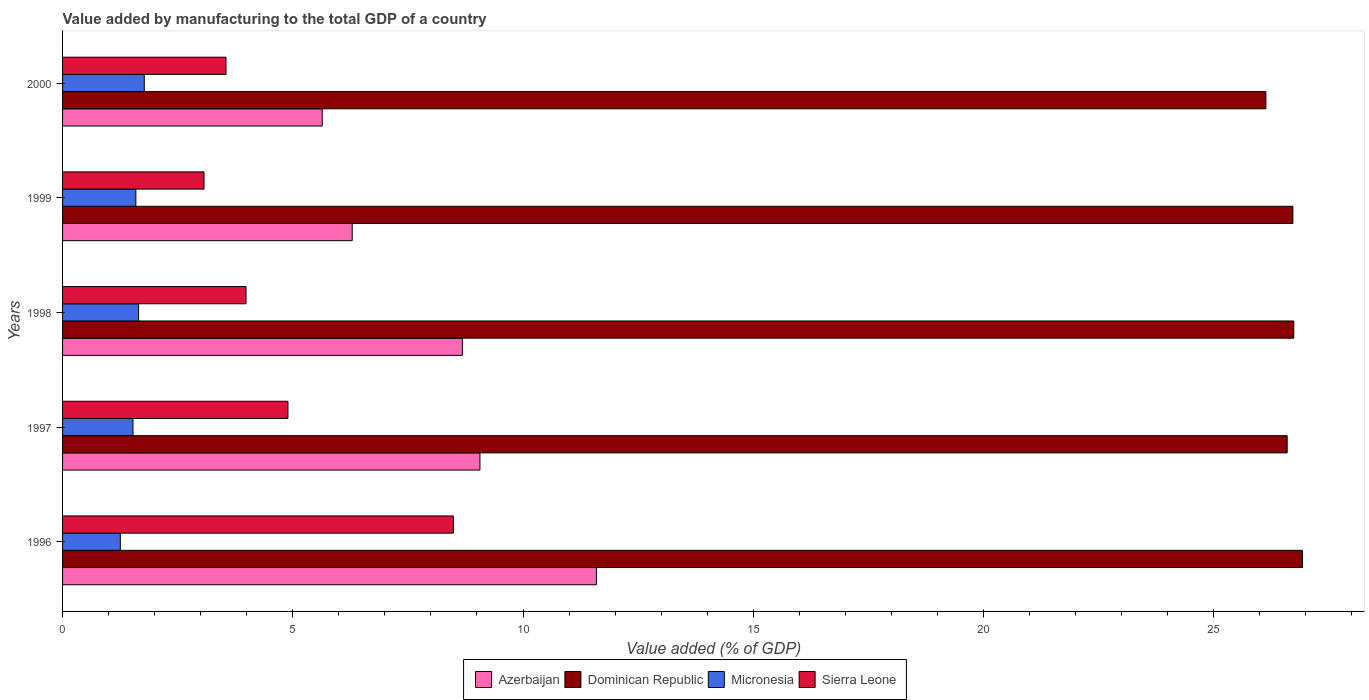How many different coloured bars are there?
Make the answer very short. 4. How many groups of bars are there?
Keep it short and to the point. 5. How many bars are there on the 3rd tick from the bottom?
Keep it short and to the point. 4. What is the value added by manufacturing to the total GDP in Dominican Republic in 1997?
Your response must be concise. 26.59. Across all years, what is the maximum value added by manufacturing to the total GDP in Sierra Leone?
Provide a succinct answer. 8.49. Across all years, what is the minimum value added by manufacturing to the total GDP in Sierra Leone?
Ensure brevity in your answer.  3.07. In which year was the value added by manufacturing to the total GDP in Dominican Republic maximum?
Your answer should be very brief. 1996. In which year was the value added by manufacturing to the total GDP in Micronesia minimum?
Offer a very short reply. 1996. What is the total value added by manufacturing to the total GDP in Sierra Leone in the graph?
Keep it short and to the point. 23.99. What is the difference between the value added by manufacturing to the total GDP in Dominican Republic in 1997 and that in 2000?
Your response must be concise. 0.46. What is the difference between the value added by manufacturing to the total GDP in Micronesia in 1997 and the value added by manufacturing to the total GDP in Sierra Leone in 1999?
Your response must be concise. -1.54. What is the average value added by manufacturing to the total GDP in Micronesia per year?
Your answer should be compact. 1.56. In the year 1999, what is the difference between the value added by manufacturing to the total GDP in Micronesia and value added by manufacturing to the total GDP in Dominican Republic?
Your answer should be very brief. -25.13. In how many years, is the value added by manufacturing to the total GDP in Azerbaijan greater than 13 %?
Your answer should be compact. 0. What is the ratio of the value added by manufacturing to the total GDP in Azerbaijan in 1996 to that in 2000?
Ensure brevity in your answer.  2.06. What is the difference between the highest and the second highest value added by manufacturing to the total GDP in Azerbaijan?
Offer a very short reply. 2.53. What is the difference between the highest and the lowest value added by manufacturing to the total GDP in Azerbaijan?
Your response must be concise. 5.95. In how many years, is the value added by manufacturing to the total GDP in Micronesia greater than the average value added by manufacturing to the total GDP in Micronesia taken over all years?
Provide a succinct answer. 3. Is the sum of the value added by manufacturing to the total GDP in Azerbaijan in 1998 and 2000 greater than the maximum value added by manufacturing to the total GDP in Sierra Leone across all years?
Offer a very short reply. Yes. What does the 2nd bar from the top in 1997 represents?
Keep it short and to the point. Micronesia. What does the 3rd bar from the bottom in 1999 represents?
Ensure brevity in your answer.  Micronesia. How many bars are there?
Make the answer very short. 20. Are all the bars in the graph horizontal?
Offer a very short reply. Yes. How many years are there in the graph?
Provide a succinct answer. 5. Does the graph contain any zero values?
Ensure brevity in your answer.  No. Does the graph contain grids?
Keep it short and to the point. No. How are the legend labels stacked?
Provide a succinct answer. Horizontal. What is the title of the graph?
Make the answer very short. Value added by manufacturing to the total GDP of a country. What is the label or title of the X-axis?
Your answer should be very brief. Value added (% of GDP). What is the label or title of the Y-axis?
Make the answer very short. Years. What is the Value added (% of GDP) of Azerbaijan in 1996?
Offer a terse response. 11.59. What is the Value added (% of GDP) of Dominican Republic in 1996?
Offer a terse response. 26.93. What is the Value added (% of GDP) in Micronesia in 1996?
Provide a short and direct response. 1.25. What is the Value added (% of GDP) of Sierra Leone in 1996?
Offer a terse response. 8.49. What is the Value added (% of GDP) of Azerbaijan in 1997?
Provide a succinct answer. 9.06. What is the Value added (% of GDP) in Dominican Republic in 1997?
Offer a very short reply. 26.59. What is the Value added (% of GDP) in Micronesia in 1997?
Your response must be concise. 1.53. What is the Value added (% of GDP) in Sierra Leone in 1997?
Give a very brief answer. 4.89. What is the Value added (% of GDP) in Azerbaijan in 1998?
Ensure brevity in your answer.  8.68. What is the Value added (% of GDP) in Dominican Republic in 1998?
Ensure brevity in your answer.  26.74. What is the Value added (% of GDP) of Micronesia in 1998?
Your answer should be compact. 1.65. What is the Value added (% of GDP) in Sierra Leone in 1998?
Ensure brevity in your answer.  3.98. What is the Value added (% of GDP) of Azerbaijan in 1999?
Your response must be concise. 6.29. What is the Value added (% of GDP) in Dominican Republic in 1999?
Provide a succinct answer. 26.72. What is the Value added (% of GDP) of Micronesia in 1999?
Provide a succinct answer. 1.59. What is the Value added (% of GDP) in Sierra Leone in 1999?
Provide a short and direct response. 3.07. What is the Value added (% of GDP) of Azerbaijan in 2000?
Your response must be concise. 5.64. What is the Value added (% of GDP) of Dominican Republic in 2000?
Ensure brevity in your answer.  26.13. What is the Value added (% of GDP) in Micronesia in 2000?
Provide a succinct answer. 1.77. What is the Value added (% of GDP) in Sierra Leone in 2000?
Provide a short and direct response. 3.55. Across all years, what is the maximum Value added (% of GDP) of Azerbaijan?
Your answer should be very brief. 11.59. Across all years, what is the maximum Value added (% of GDP) of Dominican Republic?
Your response must be concise. 26.93. Across all years, what is the maximum Value added (% of GDP) of Micronesia?
Your answer should be compact. 1.77. Across all years, what is the maximum Value added (% of GDP) of Sierra Leone?
Your answer should be very brief. 8.49. Across all years, what is the minimum Value added (% of GDP) of Azerbaijan?
Your answer should be compact. 5.64. Across all years, what is the minimum Value added (% of GDP) in Dominican Republic?
Your answer should be very brief. 26.13. Across all years, what is the minimum Value added (% of GDP) of Micronesia?
Provide a short and direct response. 1.25. Across all years, what is the minimum Value added (% of GDP) in Sierra Leone?
Provide a succinct answer. 3.07. What is the total Value added (% of GDP) in Azerbaijan in the graph?
Give a very brief answer. 41.27. What is the total Value added (% of GDP) in Dominican Republic in the graph?
Make the answer very short. 133.11. What is the total Value added (% of GDP) of Micronesia in the graph?
Give a very brief answer. 7.8. What is the total Value added (% of GDP) in Sierra Leone in the graph?
Give a very brief answer. 23.99. What is the difference between the Value added (% of GDP) in Azerbaijan in 1996 and that in 1997?
Offer a very short reply. 2.53. What is the difference between the Value added (% of GDP) of Dominican Republic in 1996 and that in 1997?
Give a very brief answer. 0.33. What is the difference between the Value added (% of GDP) in Micronesia in 1996 and that in 1997?
Offer a very short reply. -0.28. What is the difference between the Value added (% of GDP) of Sierra Leone in 1996 and that in 1997?
Keep it short and to the point. 3.59. What is the difference between the Value added (% of GDP) of Azerbaijan in 1996 and that in 1998?
Your response must be concise. 2.91. What is the difference between the Value added (% of GDP) in Dominican Republic in 1996 and that in 1998?
Your answer should be compact. 0.19. What is the difference between the Value added (% of GDP) of Micronesia in 1996 and that in 1998?
Keep it short and to the point. -0.4. What is the difference between the Value added (% of GDP) in Sierra Leone in 1996 and that in 1998?
Offer a terse response. 4.5. What is the difference between the Value added (% of GDP) of Azerbaijan in 1996 and that in 1999?
Your response must be concise. 5.3. What is the difference between the Value added (% of GDP) of Dominican Republic in 1996 and that in 1999?
Provide a short and direct response. 0.21. What is the difference between the Value added (% of GDP) of Micronesia in 1996 and that in 1999?
Offer a terse response. -0.34. What is the difference between the Value added (% of GDP) of Sierra Leone in 1996 and that in 1999?
Your answer should be very brief. 5.42. What is the difference between the Value added (% of GDP) of Azerbaijan in 1996 and that in 2000?
Your answer should be very brief. 5.95. What is the difference between the Value added (% of GDP) of Dominican Republic in 1996 and that in 2000?
Ensure brevity in your answer.  0.8. What is the difference between the Value added (% of GDP) in Micronesia in 1996 and that in 2000?
Offer a terse response. -0.52. What is the difference between the Value added (% of GDP) of Sierra Leone in 1996 and that in 2000?
Provide a succinct answer. 4.94. What is the difference between the Value added (% of GDP) in Azerbaijan in 1997 and that in 1998?
Give a very brief answer. 0.38. What is the difference between the Value added (% of GDP) in Dominican Republic in 1997 and that in 1998?
Your answer should be compact. -0.14. What is the difference between the Value added (% of GDP) of Micronesia in 1997 and that in 1998?
Ensure brevity in your answer.  -0.12. What is the difference between the Value added (% of GDP) of Sierra Leone in 1997 and that in 1998?
Provide a succinct answer. 0.91. What is the difference between the Value added (% of GDP) of Azerbaijan in 1997 and that in 1999?
Offer a very short reply. 2.77. What is the difference between the Value added (% of GDP) of Dominican Republic in 1997 and that in 1999?
Your answer should be very brief. -0.12. What is the difference between the Value added (% of GDP) in Micronesia in 1997 and that in 1999?
Offer a terse response. -0.06. What is the difference between the Value added (% of GDP) of Sierra Leone in 1997 and that in 1999?
Provide a short and direct response. 1.82. What is the difference between the Value added (% of GDP) in Azerbaijan in 1997 and that in 2000?
Give a very brief answer. 3.42. What is the difference between the Value added (% of GDP) of Dominican Republic in 1997 and that in 2000?
Ensure brevity in your answer.  0.46. What is the difference between the Value added (% of GDP) of Micronesia in 1997 and that in 2000?
Your answer should be compact. -0.25. What is the difference between the Value added (% of GDP) of Sierra Leone in 1997 and that in 2000?
Give a very brief answer. 1.35. What is the difference between the Value added (% of GDP) in Azerbaijan in 1998 and that in 1999?
Give a very brief answer. 2.39. What is the difference between the Value added (% of GDP) in Dominican Republic in 1998 and that in 1999?
Provide a succinct answer. 0.02. What is the difference between the Value added (% of GDP) in Micronesia in 1998 and that in 1999?
Give a very brief answer. 0.06. What is the difference between the Value added (% of GDP) of Sierra Leone in 1998 and that in 1999?
Provide a short and direct response. 0.91. What is the difference between the Value added (% of GDP) in Azerbaijan in 1998 and that in 2000?
Provide a succinct answer. 3.04. What is the difference between the Value added (% of GDP) of Dominican Republic in 1998 and that in 2000?
Your answer should be compact. 0.61. What is the difference between the Value added (% of GDP) in Micronesia in 1998 and that in 2000?
Your answer should be very brief. -0.12. What is the difference between the Value added (% of GDP) of Sierra Leone in 1998 and that in 2000?
Make the answer very short. 0.44. What is the difference between the Value added (% of GDP) in Azerbaijan in 1999 and that in 2000?
Provide a short and direct response. 0.65. What is the difference between the Value added (% of GDP) in Dominican Republic in 1999 and that in 2000?
Your answer should be very brief. 0.59. What is the difference between the Value added (% of GDP) of Micronesia in 1999 and that in 2000?
Ensure brevity in your answer.  -0.18. What is the difference between the Value added (% of GDP) in Sierra Leone in 1999 and that in 2000?
Your answer should be compact. -0.48. What is the difference between the Value added (% of GDP) in Azerbaijan in 1996 and the Value added (% of GDP) in Dominican Republic in 1997?
Ensure brevity in your answer.  -15. What is the difference between the Value added (% of GDP) in Azerbaijan in 1996 and the Value added (% of GDP) in Micronesia in 1997?
Give a very brief answer. 10.06. What is the difference between the Value added (% of GDP) of Azerbaijan in 1996 and the Value added (% of GDP) of Sierra Leone in 1997?
Your response must be concise. 6.7. What is the difference between the Value added (% of GDP) in Dominican Republic in 1996 and the Value added (% of GDP) in Micronesia in 1997?
Your answer should be very brief. 25.4. What is the difference between the Value added (% of GDP) in Dominican Republic in 1996 and the Value added (% of GDP) in Sierra Leone in 1997?
Your answer should be compact. 22.03. What is the difference between the Value added (% of GDP) of Micronesia in 1996 and the Value added (% of GDP) of Sierra Leone in 1997?
Your answer should be compact. -3.64. What is the difference between the Value added (% of GDP) in Azerbaijan in 1996 and the Value added (% of GDP) in Dominican Republic in 1998?
Offer a very short reply. -15.14. What is the difference between the Value added (% of GDP) in Azerbaijan in 1996 and the Value added (% of GDP) in Micronesia in 1998?
Your answer should be very brief. 9.94. What is the difference between the Value added (% of GDP) in Azerbaijan in 1996 and the Value added (% of GDP) in Sierra Leone in 1998?
Provide a succinct answer. 7.61. What is the difference between the Value added (% of GDP) in Dominican Republic in 1996 and the Value added (% of GDP) in Micronesia in 1998?
Keep it short and to the point. 25.28. What is the difference between the Value added (% of GDP) of Dominican Republic in 1996 and the Value added (% of GDP) of Sierra Leone in 1998?
Ensure brevity in your answer.  22.94. What is the difference between the Value added (% of GDP) in Micronesia in 1996 and the Value added (% of GDP) in Sierra Leone in 1998?
Your response must be concise. -2.73. What is the difference between the Value added (% of GDP) in Azerbaijan in 1996 and the Value added (% of GDP) in Dominican Republic in 1999?
Offer a very short reply. -15.12. What is the difference between the Value added (% of GDP) of Azerbaijan in 1996 and the Value added (% of GDP) of Micronesia in 1999?
Provide a short and direct response. 10. What is the difference between the Value added (% of GDP) of Azerbaijan in 1996 and the Value added (% of GDP) of Sierra Leone in 1999?
Keep it short and to the point. 8.52. What is the difference between the Value added (% of GDP) of Dominican Republic in 1996 and the Value added (% of GDP) of Micronesia in 1999?
Your answer should be very brief. 25.34. What is the difference between the Value added (% of GDP) in Dominican Republic in 1996 and the Value added (% of GDP) in Sierra Leone in 1999?
Your answer should be compact. 23.86. What is the difference between the Value added (% of GDP) of Micronesia in 1996 and the Value added (% of GDP) of Sierra Leone in 1999?
Provide a succinct answer. -1.82. What is the difference between the Value added (% of GDP) in Azerbaijan in 1996 and the Value added (% of GDP) in Dominican Republic in 2000?
Provide a short and direct response. -14.54. What is the difference between the Value added (% of GDP) in Azerbaijan in 1996 and the Value added (% of GDP) in Micronesia in 2000?
Give a very brief answer. 9.82. What is the difference between the Value added (% of GDP) in Azerbaijan in 1996 and the Value added (% of GDP) in Sierra Leone in 2000?
Provide a succinct answer. 8.04. What is the difference between the Value added (% of GDP) in Dominican Republic in 1996 and the Value added (% of GDP) in Micronesia in 2000?
Your answer should be compact. 25.15. What is the difference between the Value added (% of GDP) in Dominican Republic in 1996 and the Value added (% of GDP) in Sierra Leone in 2000?
Your answer should be very brief. 23.38. What is the difference between the Value added (% of GDP) in Micronesia in 1996 and the Value added (% of GDP) in Sierra Leone in 2000?
Provide a succinct answer. -2.3. What is the difference between the Value added (% of GDP) of Azerbaijan in 1997 and the Value added (% of GDP) of Dominican Republic in 1998?
Offer a terse response. -17.67. What is the difference between the Value added (% of GDP) in Azerbaijan in 1997 and the Value added (% of GDP) in Micronesia in 1998?
Offer a very short reply. 7.41. What is the difference between the Value added (% of GDP) in Azerbaijan in 1997 and the Value added (% of GDP) in Sierra Leone in 1998?
Offer a terse response. 5.08. What is the difference between the Value added (% of GDP) of Dominican Republic in 1997 and the Value added (% of GDP) of Micronesia in 1998?
Offer a terse response. 24.94. What is the difference between the Value added (% of GDP) of Dominican Republic in 1997 and the Value added (% of GDP) of Sierra Leone in 1998?
Ensure brevity in your answer.  22.61. What is the difference between the Value added (% of GDP) in Micronesia in 1997 and the Value added (% of GDP) in Sierra Leone in 1998?
Your answer should be compact. -2.46. What is the difference between the Value added (% of GDP) in Azerbaijan in 1997 and the Value added (% of GDP) in Dominican Republic in 1999?
Your response must be concise. -17.65. What is the difference between the Value added (% of GDP) of Azerbaijan in 1997 and the Value added (% of GDP) of Micronesia in 1999?
Offer a very short reply. 7.47. What is the difference between the Value added (% of GDP) of Azerbaijan in 1997 and the Value added (% of GDP) of Sierra Leone in 1999?
Ensure brevity in your answer.  5.99. What is the difference between the Value added (% of GDP) of Dominican Republic in 1997 and the Value added (% of GDP) of Micronesia in 1999?
Your answer should be very brief. 25. What is the difference between the Value added (% of GDP) of Dominican Republic in 1997 and the Value added (% of GDP) of Sierra Leone in 1999?
Offer a terse response. 23.52. What is the difference between the Value added (% of GDP) in Micronesia in 1997 and the Value added (% of GDP) in Sierra Leone in 1999?
Offer a very short reply. -1.54. What is the difference between the Value added (% of GDP) in Azerbaijan in 1997 and the Value added (% of GDP) in Dominican Republic in 2000?
Keep it short and to the point. -17.07. What is the difference between the Value added (% of GDP) of Azerbaijan in 1997 and the Value added (% of GDP) of Micronesia in 2000?
Ensure brevity in your answer.  7.29. What is the difference between the Value added (% of GDP) of Azerbaijan in 1997 and the Value added (% of GDP) of Sierra Leone in 2000?
Provide a succinct answer. 5.51. What is the difference between the Value added (% of GDP) in Dominican Republic in 1997 and the Value added (% of GDP) in Micronesia in 2000?
Ensure brevity in your answer.  24.82. What is the difference between the Value added (% of GDP) of Dominican Republic in 1997 and the Value added (% of GDP) of Sierra Leone in 2000?
Provide a succinct answer. 23.05. What is the difference between the Value added (% of GDP) in Micronesia in 1997 and the Value added (% of GDP) in Sierra Leone in 2000?
Ensure brevity in your answer.  -2.02. What is the difference between the Value added (% of GDP) in Azerbaijan in 1998 and the Value added (% of GDP) in Dominican Republic in 1999?
Offer a terse response. -18.04. What is the difference between the Value added (% of GDP) in Azerbaijan in 1998 and the Value added (% of GDP) in Micronesia in 1999?
Offer a terse response. 7.09. What is the difference between the Value added (% of GDP) of Azerbaijan in 1998 and the Value added (% of GDP) of Sierra Leone in 1999?
Give a very brief answer. 5.61. What is the difference between the Value added (% of GDP) of Dominican Republic in 1998 and the Value added (% of GDP) of Micronesia in 1999?
Your response must be concise. 25.15. What is the difference between the Value added (% of GDP) of Dominican Republic in 1998 and the Value added (% of GDP) of Sierra Leone in 1999?
Give a very brief answer. 23.67. What is the difference between the Value added (% of GDP) of Micronesia in 1998 and the Value added (% of GDP) of Sierra Leone in 1999?
Your response must be concise. -1.42. What is the difference between the Value added (% of GDP) in Azerbaijan in 1998 and the Value added (% of GDP) in Dominican Republic in 2000?
Your answer should be compact. -17.45. What is the difference between the Value added (% of GDP) in Azerbaijan in 1998 and the Value added (% of GDP) in Micronesia in 2000?
Keep it short and to the point. 6.91. What is the difference between the Value added (% of GDP) of Azerbaijan in 1998 and the Value added (% of GDP) of Sierra Leone in 2000?
Provide a succinct answer. 5.13. What is the difference between the Value added (% of GDP) in Dominican Republic in 1998 and the Value added (% of GDP) in Micronesia in 2000?
Your answer should be compact. 24.96. What is the difference between the Value added (% of GDP) of Dominican Republic in 1998 and the Value added (% of GDP) of Sierra Leone in 2000?
Your answer should be compact. 23.19. What is the difference between the Value added (% of GDP) of Micronesia in 1998 and the Value added (% of GDP) of Sierra Leone in 2000?
Your response must be concise. -1.9. What is the difference between the Value added (% of GDP) of Azerbaijan in 1999 and the Value added (% of GDP) of Dominican Republic in 2000?
Keep it short and to the point. -19.84. What is the difference between the Value added (% of GDP) in Azerbaijan in 1999 and the Value added (% of GDP) in Micronesia in 2000?
Your answer should be compact. 4.52. What is the difference between the Value added (% of GDP) of Azerbaijan in 1999 and the Value added (% of GDP) of Sierra Leone in 2000?
Offer a very short reply. 2.74. What is the difference between the Value added (% of GDP) of Dominican Republic in 1999 and the Value added (% of GDP) of Micronesia in 2000?
Offer a terse response. 24.94. What is the difference between the Value added (% of GDP) in Dominican Republic in 1999 and the Value added (% of GDP) in Sierra Leone in 2000?
Keep it short and to the point. 23.17. What is the difference between the Value added (% of GDP) in Micronesia in 1999 and the Value added (% of GDP) in Sierra Leone in 2000?
Ensure brevity in your answer.  -1.96. What is the average Value added (% of GDP) in Azerbaijan per year?
Make the answer very short. 8.25. What is the average Value added (% of GDP) of Dominican Republic per year?
Give a very brief answer. 26.62. What is the average Value added (% of GDP) of Micronesia per year?
Keep it short and to the point. 1.56. What is the average Value added (% of GDP) in Sierra Leone per year?
Your answer should be compact. 4.8. In the year 1996, what is the difference between the Value added (% of GDP) of Azerbaijan and Value added (% of GDP) of Dominican Republic?
Make the answer very short. -15.33. In the year 1996, what is the difference between the Value added (% of GDP) of Azerbaijan and Value added (% of GDP) of Micronesia?
Make the answer very short. 10.34. In the year 1996, what is the difference between the Value added (% of GDP) of Azerbaijan and Value added (% of GDP) of Sierra Leone?
Your answer should be very brief. 3.11. In the year 1996, what is the difference between the Value added (% of GDP) of Dominican Republic and Value added (% of GDP) of Micronesia?
Provide a short and direct response. 25.67. In the year 1996, what is the difference between the Value added (% of GDP) in Dominican Republic and Value added (% of GDP) in Sierra Leone?
Offer a very short reply. 18.44. In the year 1996, what is the difference between the Value added (% of GDP) in Micronesia and Value added (% of GDP) in Sierra Leone?
Ensure brevity in your answer.  -7.23. In the year 1997, what is the difference between the Value added (% of GDP) in Azerbaijan and Value added (% of GDP) in Dominican Republic?
Your answer should be compact. -17.53. In the year 1997, what is the difference between the Value added (% of GDP) in Azerbaijan and Value added (% of GDP) in Micronesia?
Give a very brief answer. 7.53. In the year 1997, what is the difference between the Value added (% of GDP) in Azerbaijan and Value added (% of GDP) in Sierra Leone?
Give a very brief answer. 4.17. In the year 1997, what is the difference between the Value added (% of GDP) of Dominican Republic and Value added (% of GDP) of Micronesia?
Keep it short and to the point. 25.07. In the year 1997, what is the difference between the Value added (% of GDP) of Dominican Republic and Value added (% of GDP) of Sierra Leone?
Ensure brevity in your answer.  21.7. In the year 1997, what is the difference between the Value added (% of GDP) of Micronesia and Value added (% of GDP) of Sierra Leone?
Ensure brevity in your answer.  -3.37. In the year 1998, what is the difference between the Value added (% of GDP) in Azerbaijan and Value added (% of GDP) in Dominican Republic?
Offer a terse response. -18.06. In the year 1998, what is the difference between the Value added (% of GDP) in Azerbaijan and Value added (% of GDP) in Micronesia?
Offer a very short reply. 7.03. In the year 1998, what is the difference between the Value added (% of GDP) of Azerbaijan and Value added (% of GDP) of Sierra Leone?
Make the answer very short. 4.7. In the year 1998, what is the difference between the Value added (% of GDP) of Dominican Republic and Value added (% of GDP) of Micronesia?
Provide a succinct answer. 25.09. In the year 1998, what is the difference between the Value added (% of GDP) of Dominican Republic and Value added (% of GDP) of Sierra Leone?
Ensure brevity in your answer.  22.75. In the year 1998, what is the difference between the Value added (% of GDP) in Micronesia and Value added (% of GDP) in Sierra Leone?
Provide a short and direct response. -2.33. In the year 1999, what is the difference between the Value added (% of GDP) of Azerbaijan and Value added (% of GDP) of Dominican Republic?
Give a very brief answer. -20.43. In the year 1999, what is the difference between the Value added (% of GDP) in Azerbaijan and Value added (% of GDP) in Micronesia?
Offer a terse response. 4.7. In the year 1999, what is the difference between the Value added (% of GDP) of Azerbaijan and Value added (% of GDP) of Sierra Leone?
Your answer should be very brief. 3.22. In the year 1999, what is the difference between the Value added (% of GDP) in Dominican Republic and Value added (% of GDP) in Micronesia?
Your response must be concise. 25.13. In the year 1999, what is the difference between the Value added (% of GDP) in Dominican Republic and Value added (% of GDP) in Sierra Leone?
Give a very brief answer. 23.65. In the year 1999, what is the difference between the Value added (% of GDP) of Micronesia and Value added (% of GDP) of Sierra Leone?
Provide a short and direct response. -1.48. In the year 2000, what is the difference between the Value added (% of GDP) of Azerbaijan and Value added (% of GDP) of Dominican Republic?
Your answer should be compact. -20.49. In the year 2000, what is the difference between the Value added (% of GDP) of Azerbaijan and Value added (% of GDP) of Micronesia?
Make the answer very short. 3.86. In the year 2000, what is the difference between the Value added (% of GDP) of Azerbaijan and Value added (% of GDP) of Sierra Leone?
Your answer should be compact. 2.09. In the year 2000, what is the difference between the Value added (% of GDP) in Dominican Republic and Value added (% of GDP) in Micronesia?
Provide a succinct answer. 24.36. In the year 2000, what is the difference between the Value added (% of GDP) in Dominican Republic and Value added (% of GDP) in Sierra Leone?
Make the answer very short. 22.58. In the year 2000, what is the difference between the Value added (% of GDP) of Micronesia and Value added (% of GDP) of Sierra Leone?
Make the answer very short. -1.77. What is the ratio of the Value added (% of GDP) in Azerbaijan in 1996 to that in 1997?
Keep it short and to the point. 1.28. What is the ratio of the Value added (% of GDP) of Dominican Republic in 1996 to that in 1997?
Make the answer very short. 1.01. What is the ratio of the Value added (% of GDP) of Micronesia in 1996 to that in 1997?
Make the answer very short. 0.82. What is the ratio of the Value added (% of GDP) in Sierra Leone in 1996 to that in 1997?
Provide a succinct answer. 1.73. What is the ratio of the Value added (% of GDP) in Azerbaijan in 1996 to that in 1998?
Your answer should be compact. 1.34. What is the ratio of the Value added (% of GDP) of Dominican Republic in 1996 to that in 1998?
Provide a succinct answer. 1.01. What is the ratio of the Value added (% of GDP) in Micronesia in 1996 to that in 1998?
Give a very brief answer. 0.76. What is the ratio of the Value added (% of GDP) in Sierra Leone in 1996 to that in 1998?
Your response must be concise. 2.13. What is the ratio of the Value added (% of GDP) in Azerbaijan in 1996 to that in 1999?
Keep it short and to the point. 1.84. What is the ratio of the Value added (% of GDP) of Dominican Republic in 1996 to that in 1999?
Your answer should be compact. 1.01. What is the ratio of the Value added (% of GDP) of Micronesia in 1996 to that in 1999?
Ensure brevity in your answer.  0.79. What is the ratio of the Value added (% of GDP) in Sierra Leone in 1996 to that in 1999?
Give a very brief answer. 2.76. What is the ratio of the Value added (% of GDP) in Azerbaijan in 1996 to that in 2000?
Keep it short and to the point. 2.06. What is the ratio of the Value added (% of GDP) of Dominican Republic in 1996 to that in 2000?
Offer a very short reply. 1.03. What is the ratio of the Value added (% of GDP) of Micronesia in 1996 to that in 2000?
Make the answer very short. 0.71. What is the ratio of the Value added (% of GDP) in Sierra Leone in 1996 to that in 2000?
Keep it short and to the point. 2.39. What is the ratio of the Value added (% of GDP) in Azerbaijan in 1997 to that in 1998?
Keep it short and to the point. 1.04. What is the ratio of the Value added (% of GDP) of Micronesia in 1997 to that in 1998?
Keep it short and to the point. 0.93. What is the ratio of the Value added (% of GDP) in Sierra Leone in 1997 to that in 1998?
Provide a succinct answer. 1.23. What is the ratio of the Value added (% of GDP) of Azerbaijan in 1997 to that in 1999?
Your answer should be compact. 1.44. What is the ratio of the Value added (% of GDP) in Dominican Republic in 1997 to that in 1999?
Provide a short and direct response. 1. What is the ratio of the Value added (% of GDP) of Micronesia in 1997 to that in 1999?
Your response must be concise. 0.96. What is the ratio of the Value added (% of GDP) in Sierra Leone in 1997 to that in 1999?
Offer a terse response. 1.59. What is the ratio of the Value added (% of GDP) in Azerbaijan in 1997 to that in 2000?
Your response must be concise. 1.61. What is the ratio of the Value added (% of GDP) of Dominican Republic in 1997 to that in 2000?
Provide a short and direct response. 1.02. What is the ratio of the Value added (% of GDP) in Micronesia in 1997 to that in 2000?
Provide a succinct answer. 0.86. What is the ratio of the Value added (% of GDP) in Sierra Leone in 1997 to that in 2000?
Your answer should be very brief. 1.38. What is the ratio of the Value added (% of GDP) of Azerbaijan in 1998 to that in 1999?
Your response must be concise. 1.38. What is the ratio of the Value added (% of GDP) in Dominican Republic in 1998 to that in 1999?
Your response must be concise. 1. What is the ratio of the Value added (% of GDP) of Micronesia in 1998 to that in 1999?
Provide a short and direct response. 1.04. What is the ratio of the Value added (% of GDP) in Sierra Leone in 1998 to that in 1999?
Make the answer very short. 1.3. What is the ratio of the Value added (% of GDP) in Azerbaijan in 1998 to that in 2000?
Provide a succinct answer. 1.54. What is the ratio of the Value added (% of GDP) in Dominican Republic in 1998 to that in 2000?
Give a very brief answer. 1.02. What is the ratio of the Value added (% of GDP) in Sierra Leone in 1998 to that in 2000?
Provide a short and direct response. 1.12. What is the ratio of the Value added (% of GDP) in Azerbaijan in 1999 to that in 2000?
Your response must be concise. 1.12. What is the ratio of the Value added (% of GDP) in Dominican Republic in 1999 to that in 2000?
Provide a short and direct response. 1.02. What is the ratio of the Value added (% of GDP) of Micronesia in 1999 to that in 2000?
Provide a short and direct response. 0.9. What is the ratio of the Value added (% of GDP) in Sierra Leone in 1999 to that in 2000?
Provide a short and direct response. 0.87. What is the difference between the highest and the second highest Value added (% of GDP) of Azerbaijan?
Your response must be concise. 2.53. What is the difference between the highest and the second highest Value added (% of GDP) in Dominican Republic?
Provide a short and direct response. 0.19. What is the difference between the highest and the second highest Value added (% of GDP) in Micronesia?
Keep it short and to the point. 0.12. What is the difference between the highest and the second highest Value added (% of GDP) of Sierra Leone?
Provide a short and direct response. 3.59. What is the difference between the highest and the lowest Value added (% of GDP) in Azerbaijan?
Keep it short and to the point. 5.95. What is the difference between the highest and the lowest Value added (% of GDP) of Dominican Republic?
Provide a succinct answer. 0.8. What is the difference between the highest and the lowest Value added (% of GDP) in Micronesia?
Your response must be concise. 0.52. What is the difference between the highest and the lowest Value added (% of GDP) of Sierra Leone?
Make the answer very short. 5.42. 